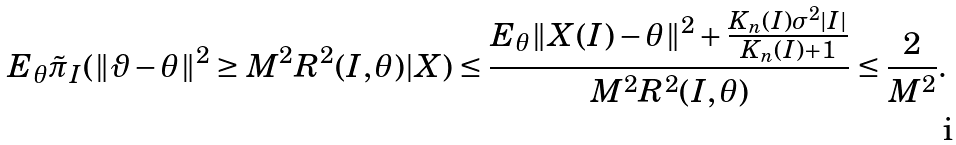Convert formula to latex. <formula><loc_0><loc_0><loc_500><loc_500>E _ { \theta } \tilde { \pi } _ { I } ( \| \vartheta - \theta \| ^ { 2 } & \geq M ^ { 2 } R ^ { 2 } ( I , \theta ) | X ) \leq \frac { E _ { \theta } \| X ( I ) - \theta \| ^ { 2 } + \frac { K _ { n } ( I ) \sigma ^ { 2 } | I | } { K _ { n } ( I ) + 1 } } { M ^ { 2 } R ^ { 2 } ( I , \theta ) } \leq \frac { 2 } { M ^ { 2 } } .</formula> 